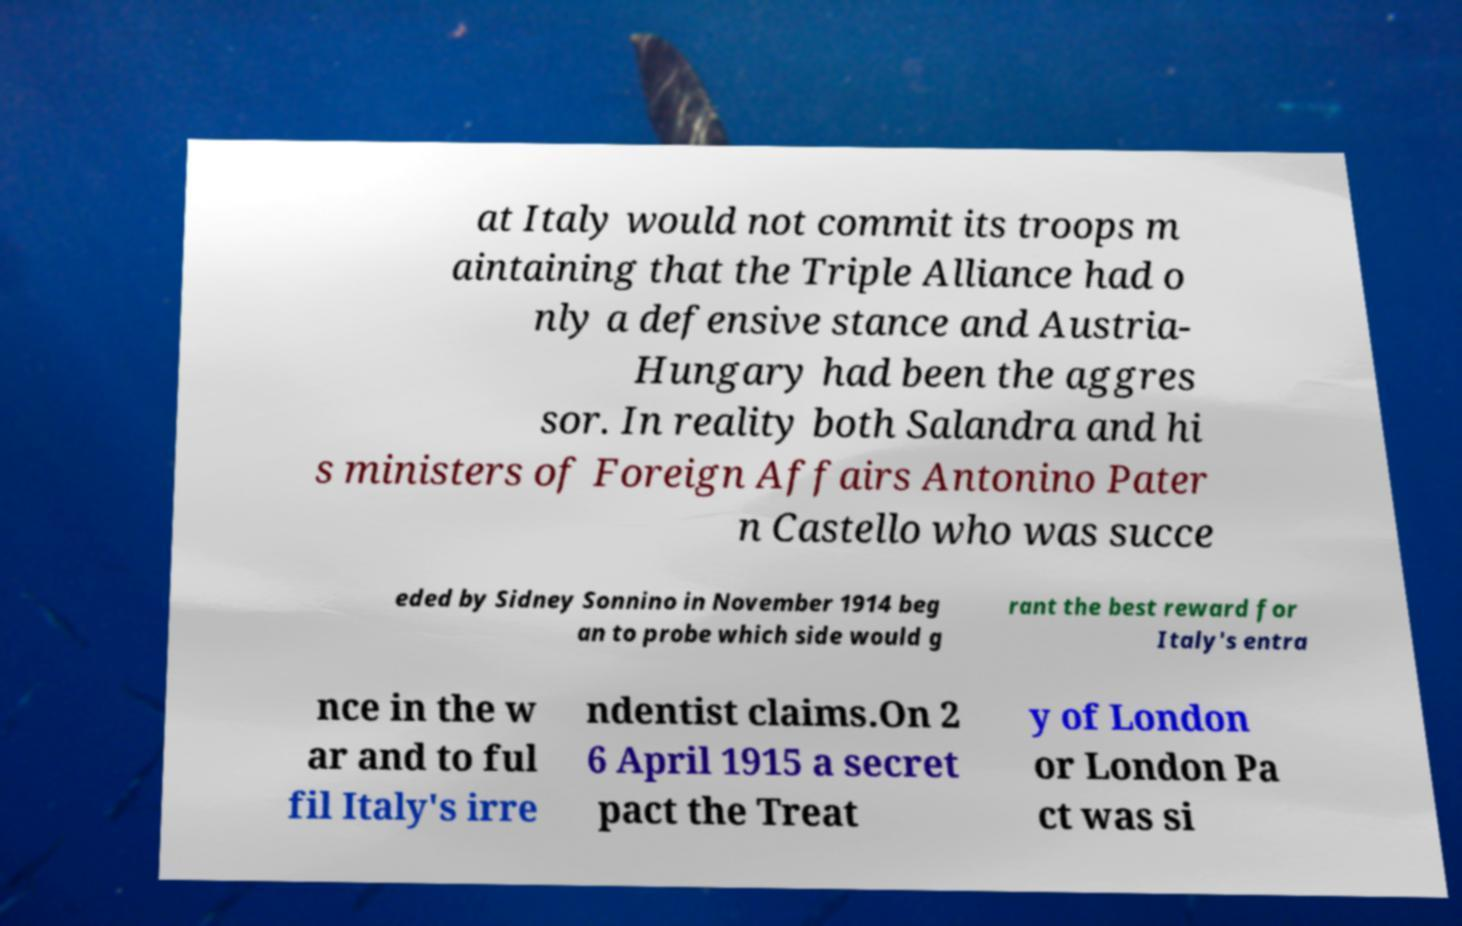Please identify and transcribe the text found in this image. at Italy would not commit its troops m aintaining that the Triple Alliance had o nly a defensive stance and Austria- Hungary had been the aggres sor. In reality both Salandra and hi s ministers of Foreign Affairs Antonino Pater n Castello who was succe eded by Sidney Sonnino in November 1914 beg an to probe which side would g rant the best reward for Italy's entra nce in the w ar and to ful fil Italy's irre ndentist claims.On 2 6 April 1915 a secret pact the Treat y of London or London Pa ct was si 